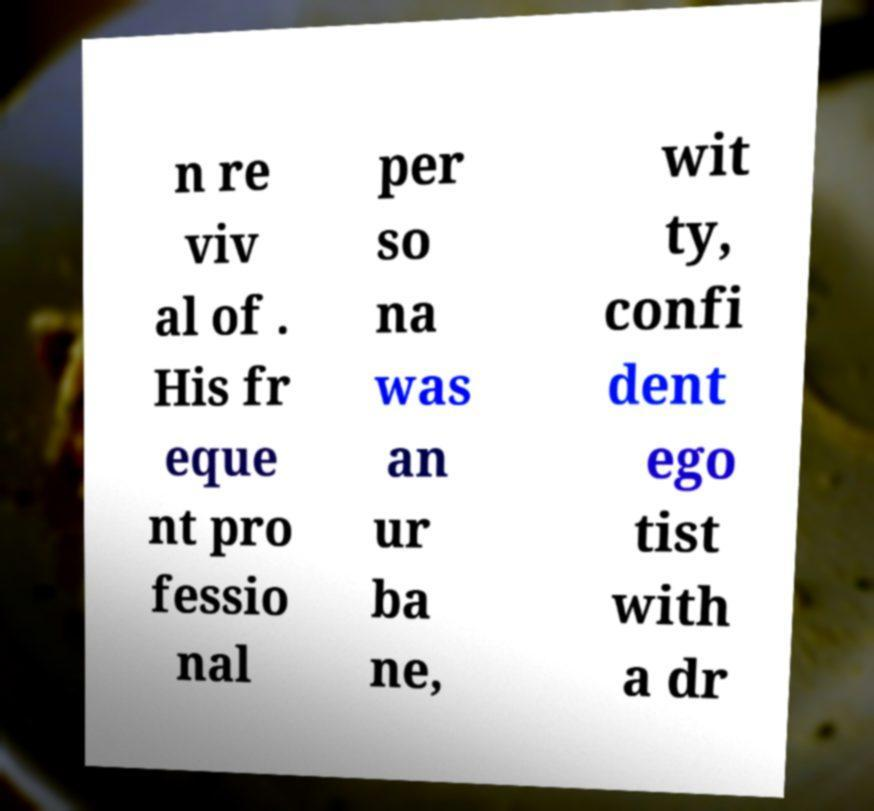For documentation purposes, I need the text within this image transcribed. Could you provide that? n re viv al of . His fr eque nt pro fessio nal per so na was an ur ba ne, wit ty, confi dent ego tist with a dr 